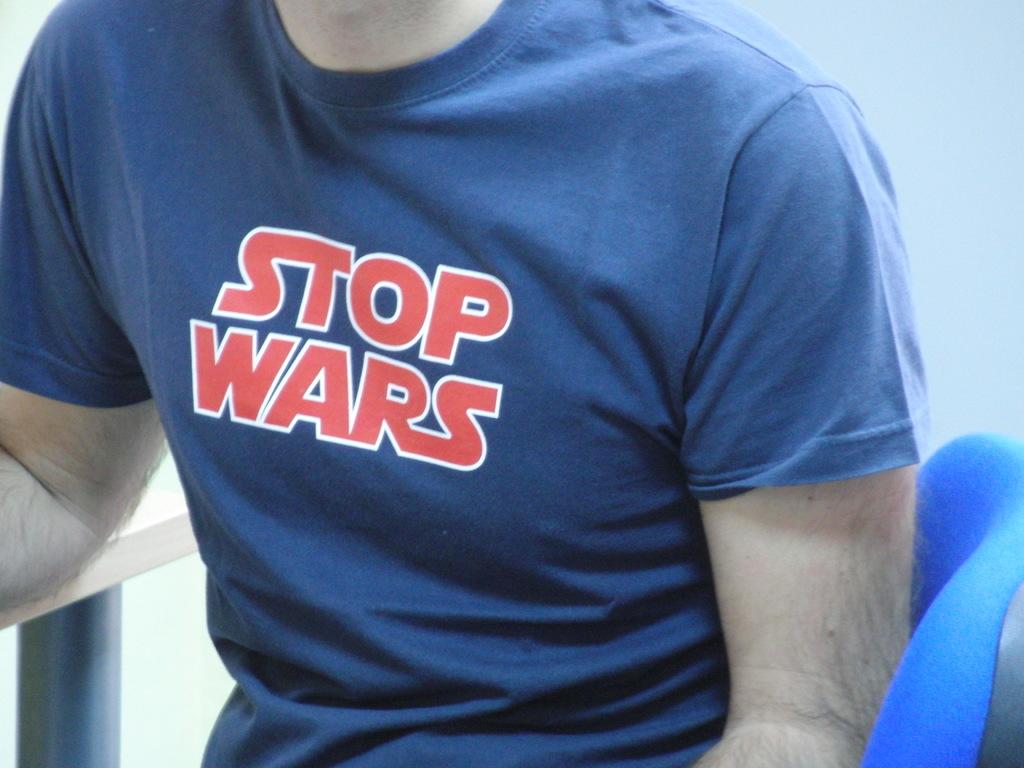What´s the color of the t-shirt?
Give a very brief answer. Blue. 